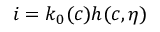Convert formula to latex. <formula><loc_0><loc_0><loc_500><loc_500>i = k _ { 0 } ( c ) h ( c , \eta )</formula> 